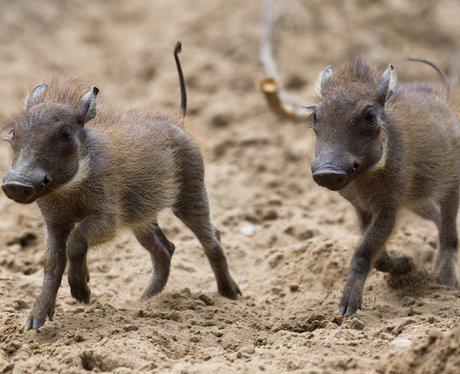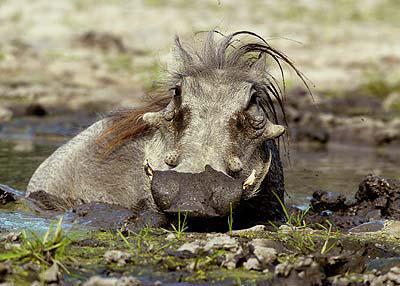The first image is the image on the left, the second image is the image on the right. For the images displayed, is the sentence "At least one warthog is wading in mud in one of the images." factually correct? Answer yes or no. Yes. The first image is the image on the left, the second image is the image on the right. Evaluate the accuracy of this statement regarding the images: "The right image contains no more than two wart hogs.". Is it true? Answer yes or no. Yes. 